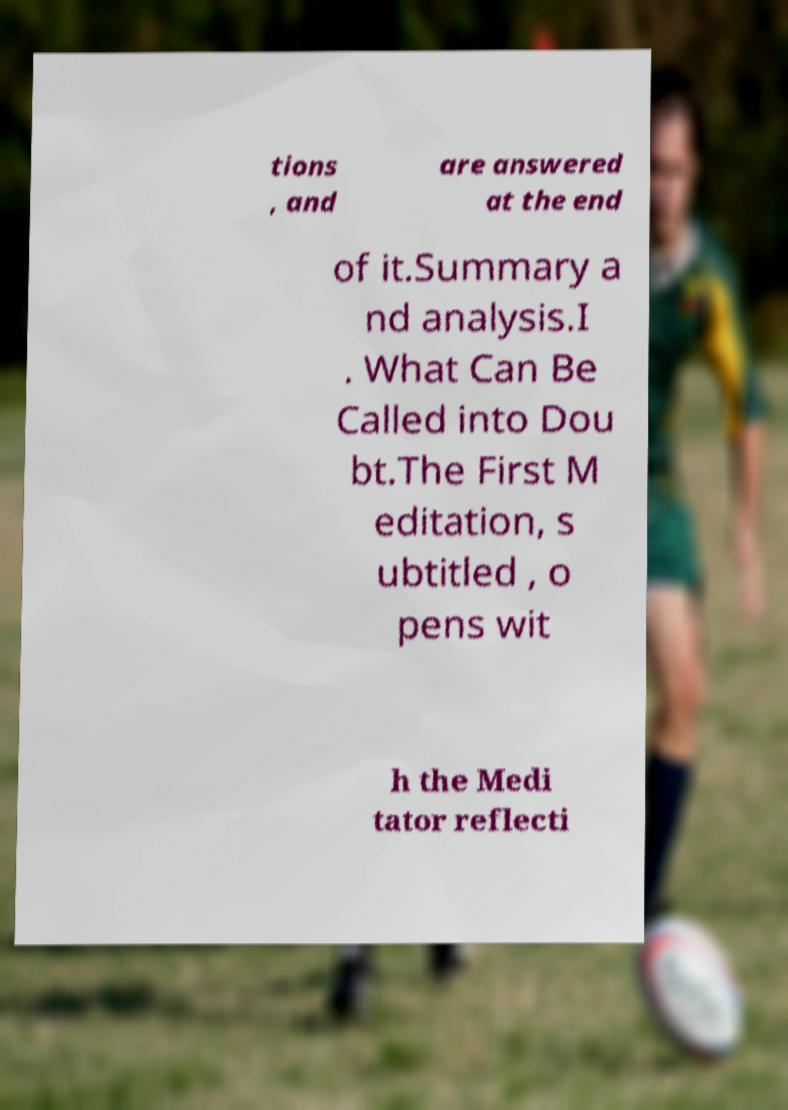Could you extract and type out the text from this image? tions , and are answered at the end of it.Summary a nd analysis.I . What Can Be Called into Dou bt.The First M editation, s ubtitled , o pens wit h the Medi tator reflecti 